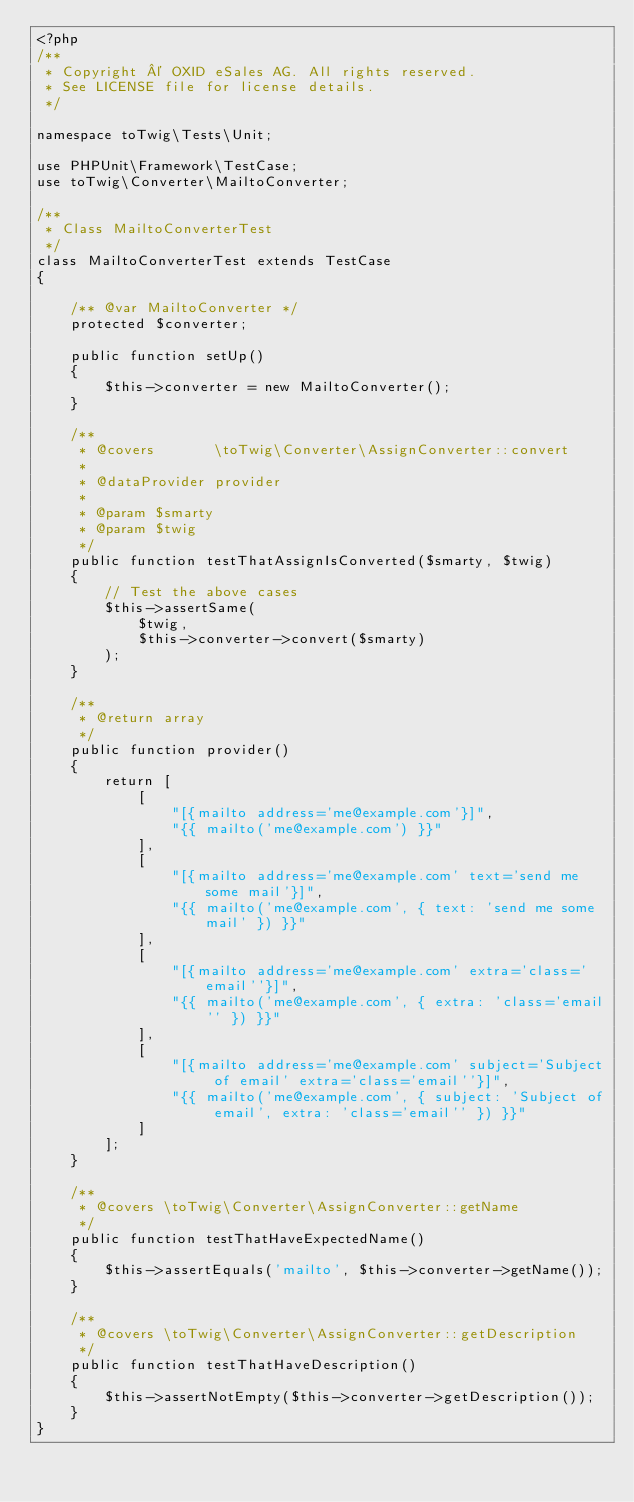Convert code to text. <code><loc_0><loc_0><loc_500><loc_500><_PHP_><?php
/**
 * Copyright © OXID eSales AG. All rights reserved.
 * See LICENSE file for license details.
 */

namespace toTwig\Tests\Unit;

use PHPUnit\Framework\TestCase;
use toTwig\Converter\MailtoConverter;

/**
 * Class MailtoConverterTest
 */
class MailtoConverterTest extends TestCase
{

    /** @var MailtoConverter */
    protected $converter;

    public function setUp()
    {
        $this->converter = new MailtoConverter();
    }

    /**
     * @covers       \toTwig\Converter\AssignConverter::convert
     *
     * @dataProvider provider
     *
     * @param $smarty
     * @param $twig
     */
    public function testThatAssignIsConverted($smarty, $twig)
    {
        // Test the above cases
        $this->assertSame(
            $twig,
            $this->converter->convert($smarty)
        );
    }

    /**
     * @return array
     */
    public function provider()
    {
        return [
            [
                "[{mailto address='me@example.com'}]",
                "{{ mailto('me@example.com') }}"
            ],
            [
                "[{mailto address='me@example.com' text='send me some mail'}]",
                "{{ mailto('me@example.com', { text: 'send me some mail' }) }}"
            ],
            [
                "[{mailto address='me@example.com' extra='class='email''}]",
                "{{ mailto('me@example.com', { extra: 'class='email'' }) }}"
            ],
            [
                "[{mailto address='me@example.com' subject='Subject of email' extra='class='email''}]",
                "{{ mailto('me@example.com', { subject: 'Subject of email', extra: 'class='email'' }) }}"
            ]
        ];
    }

    /**
     * @covers \toTwig\Converter\AssignConverter::getName
     */
    public function testThatHaveExpectedName()
    {
        $this->assertEquals('mailto', $this->converter->getName());
    }

    /**
     * @covers \toTwig\Converter\AssignConverter::getDescription
     */
    public function testThatHaveDescription()
    {
        $this->assertNotEmpty($this->converter->getDescription());
    }
}
</code> 